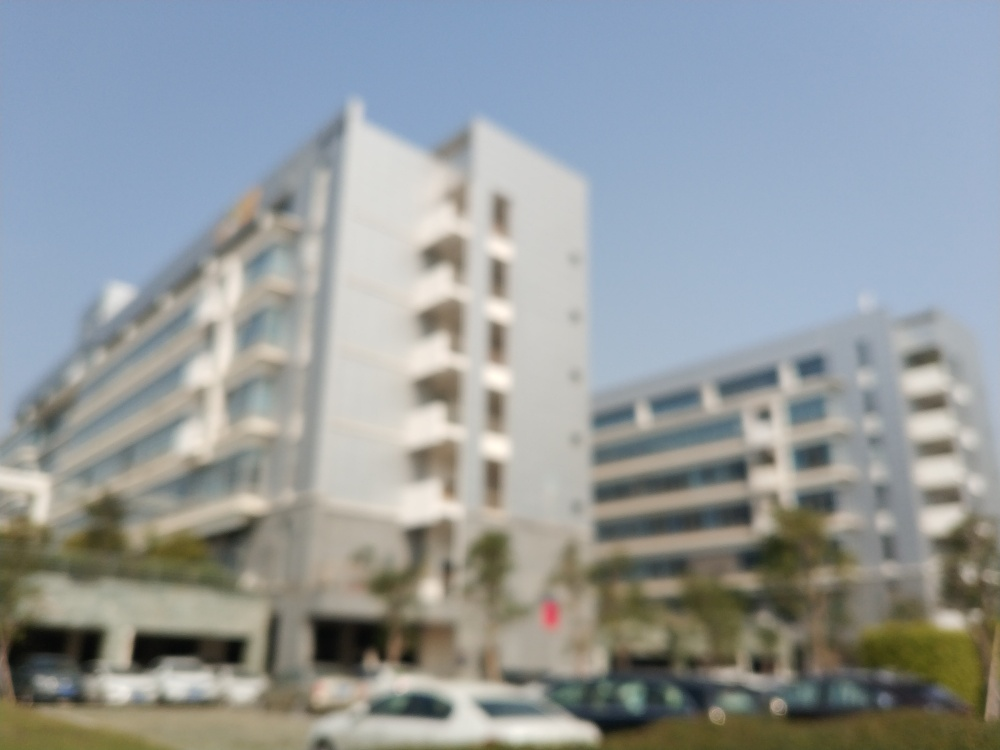Is the image free from noise? The image contains a significant amount of blur, which obscures the details. This visual imperfection could be likened to what one might describe as 'noise' in a photographic context. So, indeed, the image does not present a clear and noise-free quality. 